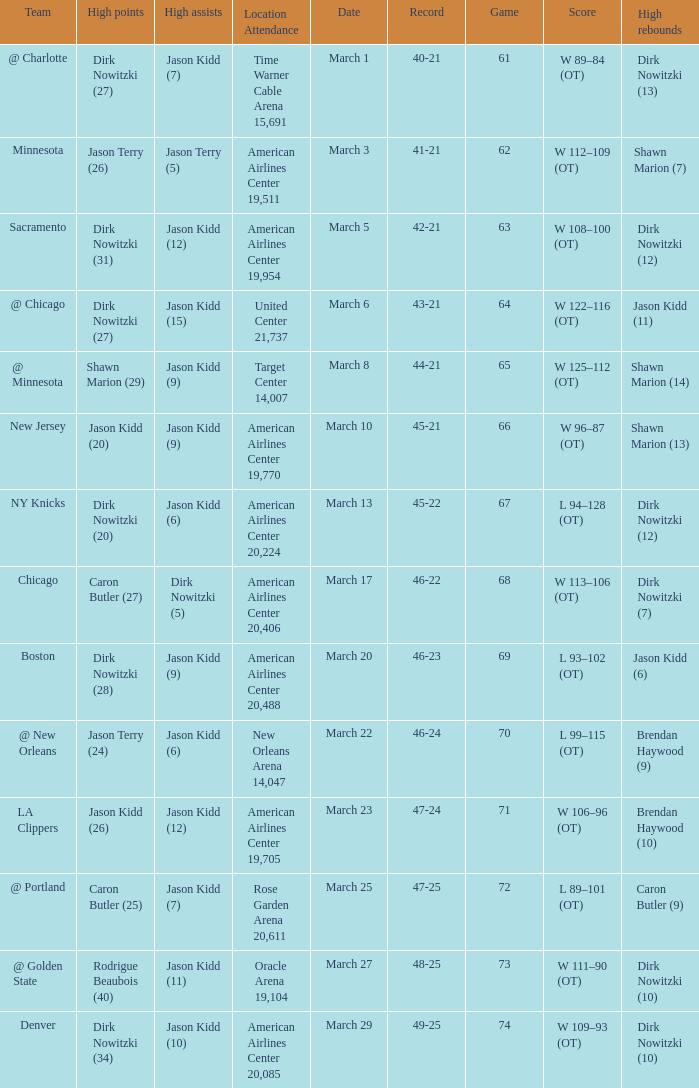How many games had been played when the Mavericks had a 46-22 record? 68.0. 